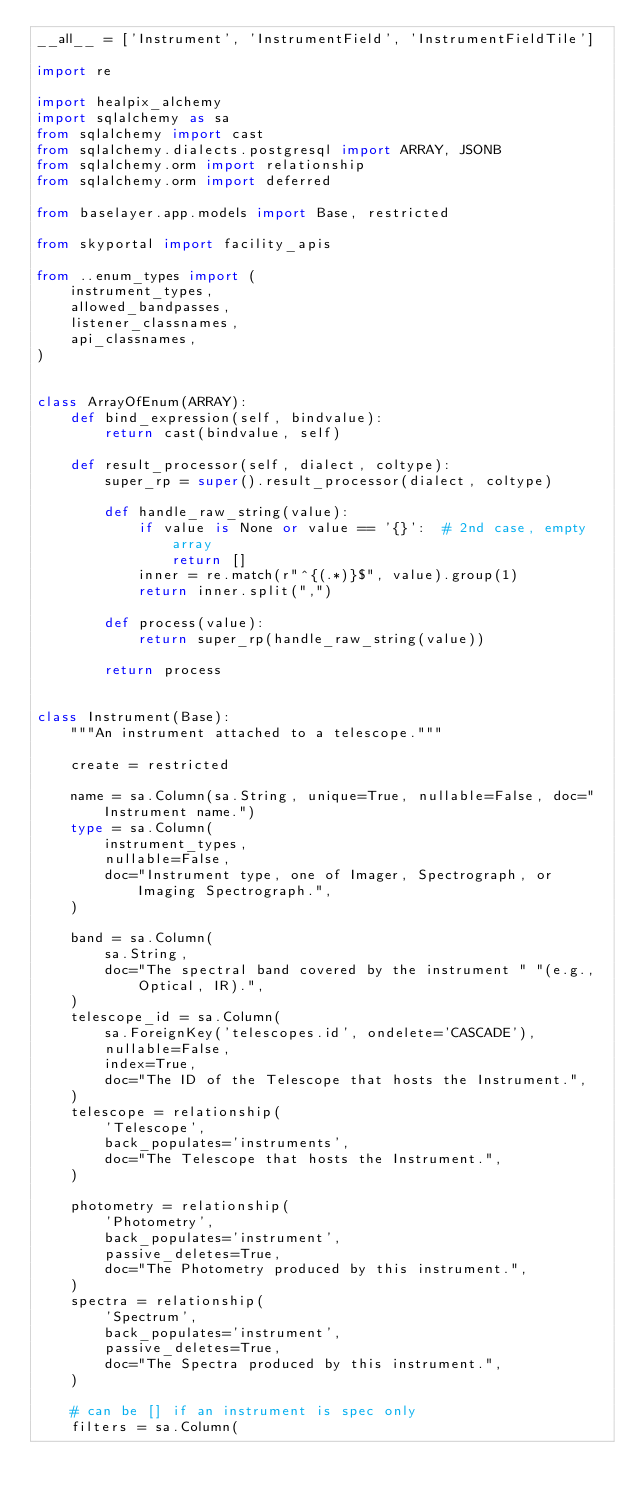<code> <loc_0><loc_0><loc_500><loc_500><_Python_>__all__ = ['Instrument', 'InstrumentField', 'InstrumentFieldTile']

import re

import healpix_alchemy
import sqlalchemy as sa
from sqlalchemy import cast
from sqlalchemy.dialects.postgresql import ARRAY, JSONB
from sqlalchemy.orm import relationship
from sqlalchemy.orm import deferred

from baselayer.app.models import Base, restricted

from skyportal import facility_apis

from ..enum_types import (
    instrument_types,
    allowed_bandpasses,
    listener_classnames,
    api_classnames,
)


class ArrayOfEnum(ARRAY):
    def bind_expression(self, bindvalue):
        return cast(bindvalue, self)

    def result_processor(self, dialect, coltype):
        super_rp = super().result_processor(dialect, coltype)

        def handle_raw_string(value):
            if value is None or value == '{}':  # 2nd case, empty array
                return []
            inner = re.match(r"^{(.*)}$", value).group(1)
            return inner.split(",")

        def process(value):
            return super_rp(handle_raw_string(value))

        return process


class Instrument(Base):
    """An instrument attached to a telescope."""

    create = restricted

    name = sa.Column(sa.String, unique=True, nullable=False, doc="Instrument name.")
    type = sa.Column(
        instrument_types,
        nullable=False,
        doc="Instrument type, one of Imager, Spectrograph, or Imaging Spectrograph.",
    )

    band = sa.Column(
        sa.String,
        doc="The spectral band covered by the instrument " "(e.g., Optical, IR).",
    )
    telescope_id = sa.Column(
        sa.ForeignKey('telescopes.id', ondelete='CASCADE'),
        nullable=False,
        index=True,
        doc="The ID of the Telescope that hosts the Instrument.",
    )
    telescope = relationship(
        'Telescope',
        back_populates='instruments',
        doc="The Telescope that hosts the Instrument.",
    )

    photometry = relationship(
        'Photometry',
        back_populates='instrument',
        passive_deletes=True,
        doc="The Photometry produced by this instrument.",
    )
    spectra = relationship(
        'Spectrum',
        back_populates='instrument',
        passive_deletes=True,
        doc="The Spectra produced by this instrument.",
    )

    # can be [] if an instrument is spec only
    filters = sa.Column(</code> 